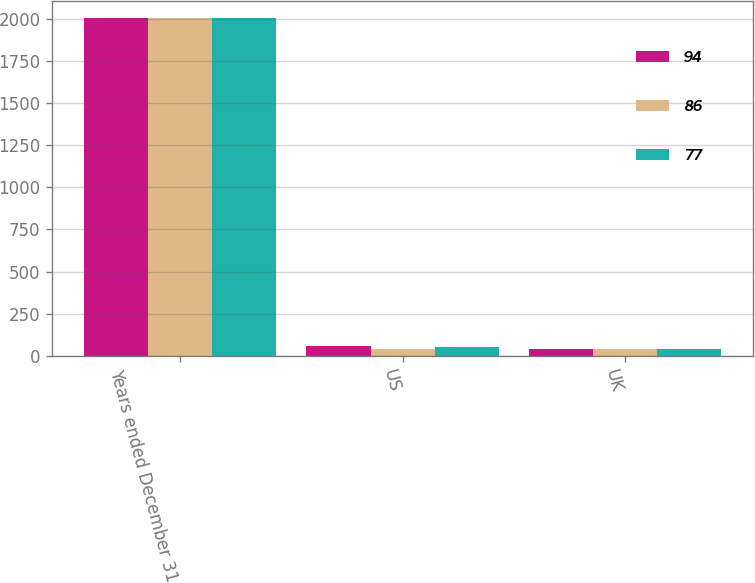Convert chart to OTSL. <chart><loc_0><loc_0><loc_500><loc_500><stacked_bar_chart><ecel><fcel>Years ended December 31<fcel>US<fcel>UK<nl><fcel>94<fcel>2009<fcel>56<fcel>38<nl><fcel>86<fcel>2008<fcel>37<fcel>40<nl><fcel>77<fcel>2007<fcel>49<fcel>37<nl></chart> 